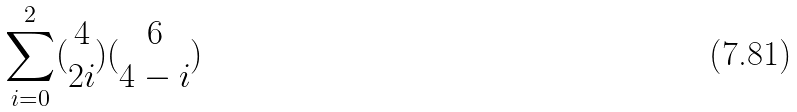<formula> <loc_0><loc_0><loc_500><loc_500>\sum _ { i = 0 } ^ { 2 } ( \begin{matrix} 4 \\ 2 i \end{matrix} ) ( \begin{matrix} 6 \\ 4 - i \end{matrix} )</formula> 